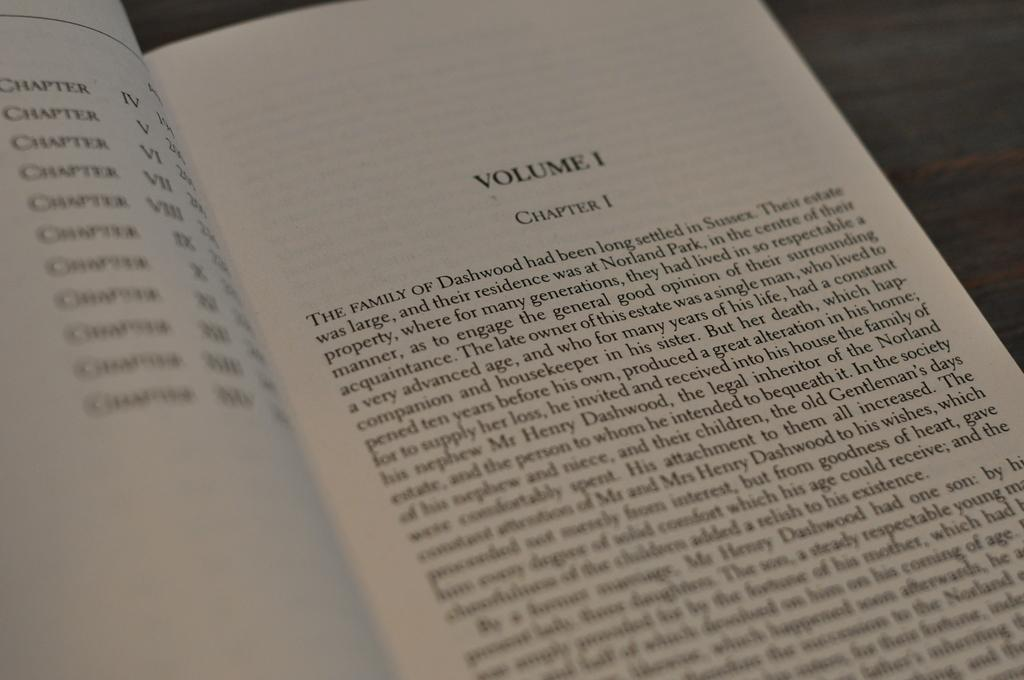<image>
Write a terse but informative summary of the picture. Open book on Volume 1 Chapter 1 Starting with the words "The Family". 